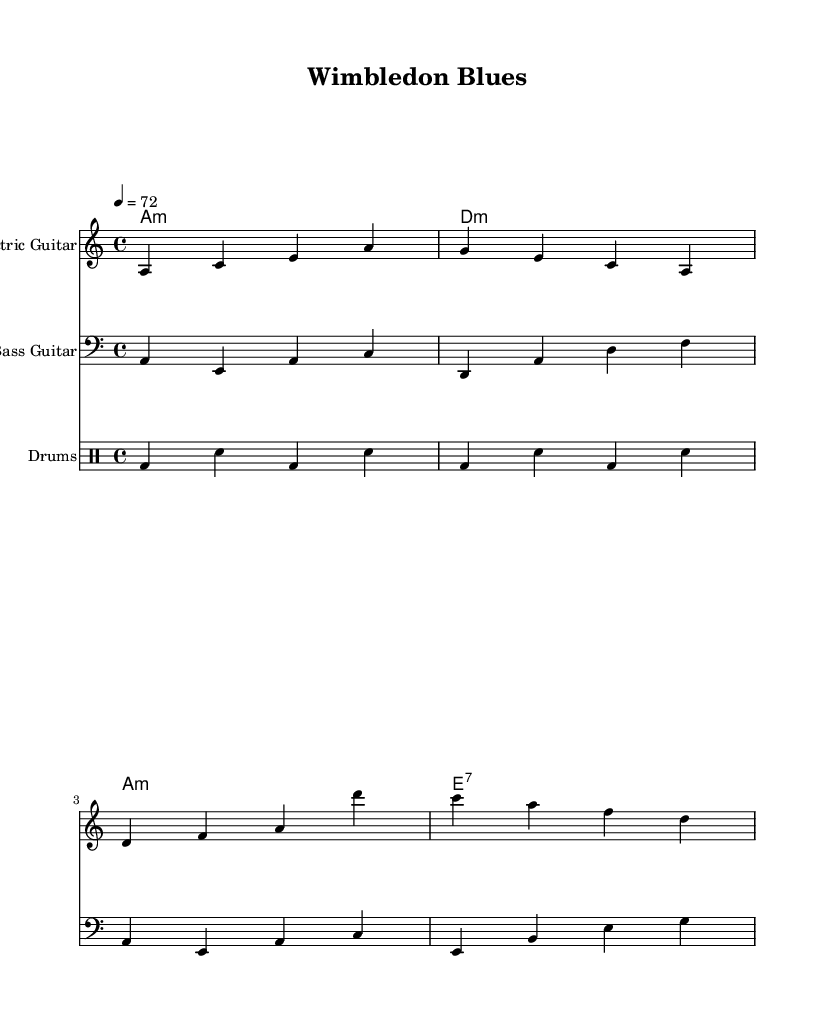What is the key signature of this music? The key signature indicates a minor tonality, specifically A minor, which typically has no sharps or flats. You can identify this by looking at the key signature at the beginning of the staff lines, which aligns with the note A as the tonic.
Answer: A minor What is the time signature of this music? The time signature is shown in the denominator and numerator at the beginning of the piece. In this score, it is written as \(4/4\), which means four beats per measure, and each quarter note receives one beat.
Answer: 4/4 What is the tempo marking of this music? The tempo marking is indicated at the beginning of the score where it states "4 = 72." This means that the quarter note (4) is to be played at a speed of 72 beats per minute.
Answer: 72 How many measures are in the electric guitar part? The electric guitar part consists of four measures, as indicated by counting the groupings of notes from the start of the part until a section is completed. Each group of notes separated by the vertical bar represents one measure.
Answer: 4 Which chord is played in the first measure? The chord played in the first measure is specified in the chord names section. In this case, it corresponds to A minor, as denoted by the A and the small "m" following it. The chord descriptions align with the melody in the electric guitar part.
Answer: A minor What instruments are included in this score? The score includes three different instruments: Electric Guitar, Bass Guitar, and Drums. Each section is clearly labeled at the beginning of each staff, indicating the respective instrument played.
Answer: Electric Guitar, Bass Guitar, Drums What type of music is this an example of? The title "Wimbledon Blues" and the overall style of the score indicate that this is an electric blues piece. The structure, chord progressions, and stylistic elements are characteristic of the blues genre, particularly in an electric format.
Answer: Electric Blues 